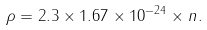<formula> <loc_0><loc_0><loc_500><loc_500>\rho = 2 . 3 \times 1 . 6 7 \times 1 0 ^ { - 2 4 } \times n .</formula> 